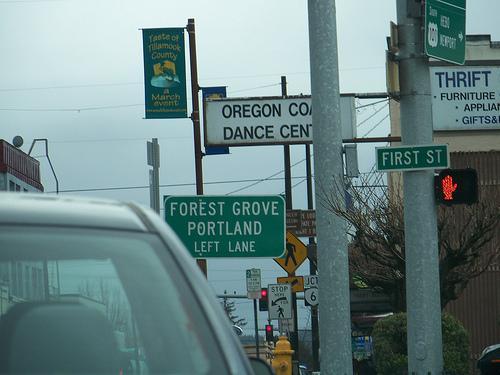How many cars are in this picture?
Give a very brief answer. 1. 